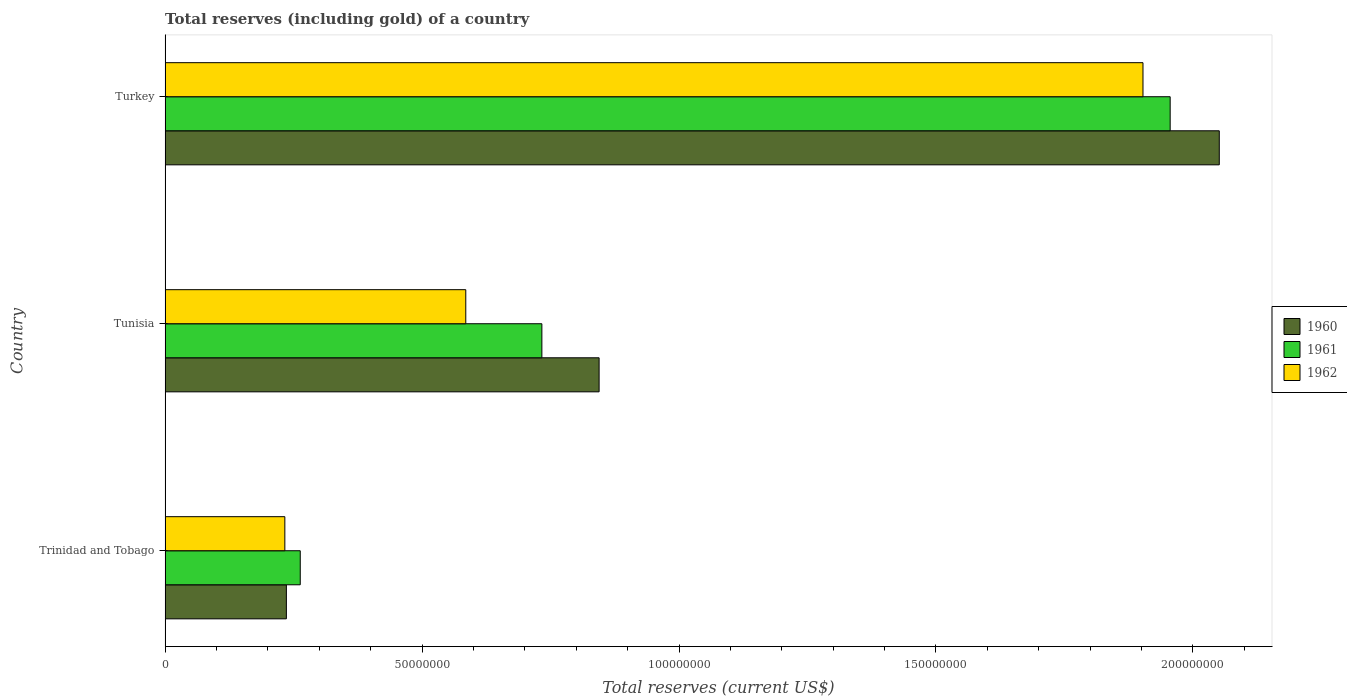How many different coloured bars are there?
Provide a short and direct response. 3. Are the number of bars on each tick of the Y-axis equal?
Ensure brevity in your answer.  Yes. How many bars are there on the 1st tick from the top?
Your answer should be compact. 3. What is the label of the 2nd group of bars from the top?
Your response must be concise. Tunisia. What is the total reserves (including gold) in 1960 in Tunisia?
Offer a very short reply. 8.45e+07. Across all countries, what is the maximum total reserves (including gold) in 1962?
Provide a short and direct response. 1.90e+08. Across all countries, what is the minimum total reserves (including gold) in 1960?
Your answer should be very brief. 2.36e+07. In which country was the total reserves (including gold) in 1960 minimum?
Your response must be concise. Trinidad and Tobago. What is the total total reserves (including gold) in 1960 in the graph?
Your response must be concise. 3.13e+08. What is the difference between the total reserves (including gold) in 1960 in Trinidad and Tobago and that in Tunisia?
Your answer should be very brief. -6.09e+07. What is the difference between the total reserves (including gold) in 1960 in Tunisia and the total reserves (including gold) in 1962 in Trinidad and Tobago?
Give a very brief answer. 6.12e+07. What is the average total reserves (including gold) in 1960 per country?
Ensure brevity in your answer.  1.04e+08. What is the difference between the total reserves (including gold) in 1962 and total reserves (including gold) in 1960 in Turkey?
Provide a short and direct response. -1.48e+07. In how many countries, is the total reserves (including gold) in 1962 greater than 150000000 US$?
Give a very brief answer. 1. What is the ratio of the total reserves (including gold) in 1962 in Trinidad and Tobago to that in Tunisia?
Your response must be concise. 0.4. What is the difference between the highest and the second highest total reserves (including gold) in 1960?
Offer a very short reply. 1.21e+08. What is the difference between the highest and the lowest total reserves (including gold) in 1960?
Provide a succinct answer. 1.82e+08. What does the 1st bar from the top in Trinidad and Tobago represents?
Provide a succinct answer. 1962. What does the 2nd bar from the bottom in Tunisia represents?
Provide a short and direct response. 1961. How many bars are there?
Provide a succinct answer. 9. How many countries are there in the graph?
Your answer should be compact. 3. What is the difference between two consecutive major ticks on the X-axis?
Offer a terse response. 5.00e+07. Does the graph contain any zero values?
Provide a short and direct response. No. How are the legend labels stacked?
Give a very brief answer. Vertical. What is the title of the graph?
Your response must be concise. Total reserves (including gold) of a country. What is the label or title of the X-axis?
Provide a succinct answer. Total reserves (current US$). What is the Total reserves (current US$) of 1960 in Trinidad and Tobago?
Your response must be concise. 2.36e+07. What is the Total reserves (current US$) of 1961 in Trinidad and Tobago?
Your answer should be compact. 2.63e+07. What is the Total reserves (current US$) of 1962 in Trinidad and Tobago?
Give a very brief answer. 2.33e+07. What is the Total reserves (current US$) in 1960 in Tunisia?
Give a very brief answer. 8.45e+07. What is the Total reserves (current US$) in 1961 in Tunisia?
Provide a succinct answer. 7.33e+07. What is the Total reserves (current US$) of 1962 in Tunisia?
Provide a succinct answer. 5.85e+07. What is the Total reserves (current US$) of 1960 in Turkey?
Your answer should be very brief. 2.05e+08. What is the Total reserves (current US$) in 1961 in Turkey?
Make the answer very short. 1.96e+08. What is the Total reserves (current US$) in 1962 in Turkey?
Your answer should be very brief. 1.90e+08. Across all countries, what is the maximum Total reserves (current US$) of 1960?
Provide a short and direct response. 2.05e+08. Across all countries, what is the maximum Total reserves (current US$) in 1961?
Provide a short and direct response. 1.96e+08. Across all countries, what is the maximum Total reserves (current US$) in 1962?
Provide a succinct answer. 1.90e+08. Across all countries, what is the minimum Total reserves (current US$) in 1960?
Offer a very short reply. 2.36e+07. Across all countries, what is the minimum Total reserves (current US$) in 1961?
Ensure brevity in your answer.  2.63e+07. Across all countries, what is the minimum Total reserves (current US$) of 1962?
Make the answer very short. 2.33e+07. What is the total Total reserves (current US$) of 1960 in the graph?
Your answer should be compact. 3.13e+08. What is the total Total reserves (current US$) of 1961 in the graph?
Offer a very short reply. 2.95e+08. What is the total Total reserves (current US$) in 1962 in the graph?
Your answer should be compact. 2.72e+08. What is the difference between the Total reserves (current US$) in 1960 in Trinidad and Tobago and that in Tunisia?
Your answer should be very brief. -6.09e+07. What is the difference between the Total reserves (current US$) in 1961 in Trinidad and Tobago and that in Tunisia?
Offer a very short reply. -4.70e+07. What is the difference between the Total reserves (current US$) in 1962 in Trinidad and Tobago and that in Tunisia?
Your answer should be compact. -3.52e+07. What is the difference between the Total reserves (current US$) of 1960 in Trinidad and Tobago and that in Turkey?
Provide a short and direct response. -1.82e+08. What is the difference between the Total reserves (current US$) of 1961 in Trinidad and Tobago and that in Turkey?
Offer a terse response. -1.69e+08. What is the difference between the Total reserves (current US$) of 1962 in Trinidad and Tobago and that in Turkey?
Make the answer very short. -1.67e+08. What is the difference between the Total reserves (current US$) of 1960 in Tunisia and that in Turkey?
Make the answer very short. -1.21e+08. What is the difference between the Total reserves (current US$) in 1961 in Tunisia and that in Turkey?
Your response must be concise. -1.22e+08. What is the difference between the Total reserves (current US$) in 1962 in Tunisia and that in Turkey?
Offer a terse response. -1.32e+08. What is the difference between the Total reserves (current US$) in 1960 in Trinidad and Tobago and the Total reserves (current US$) in 1961 in Tunisia?
Ensure brevity in your answer.  -4.97e+07. What is the difference between the Total reserves (current US$) in 1960 in Trinidad and Tobago and the Total reserves (current US$) in 1962 in Tunisia?
Ensure brevity in your answer.  -3.49e+07. What is the difference between the Total reserves (current US$) in 1961 in Trinidad and Tobago and the Total reserves (current US$) in 1962 in Tunisia?
Make the answer very short. -3.22e+07. What is the difference between the Total reserves (current US$) in 1960 in Trinidad and Tobago and the Total reserves (current US$) in 1961 in Turkey?
Ensure brevity in your answer.  -1.72e+08. What is the difference between the Total reserves (current US$) of 1960 in Trinidad and Tobago and the Total reserves (current US$) of 1962 in Turkey?
Your response must be concise. -1.67e+08. What is the difference between the Total reserves (current US$) in 1961 in Trinidad and Tobago and the Total reserves (current US$) in 1962 in Turkey?
Make the answer very short. -1.64e+08. What is the difference between the Total reserves (current US$) of 1960 in Tunisia and the Total reserves (current US$) of 1961 in Turkey?
Your answer should be compact. -1.11e+08. What is the difference between the Total reserves (current US$) in 1960 in Tunisia and the Total reserves (current US$) in 1962 in Turkey?
Provide a short and direct response. -1.06e+08. What is the difference between the Total reserves (current US$) in 1961 in Tunisia and the Total reserves (current US$) in 1962 in Turkey?
Provide a short and direct response. -1.17e+08. What is the average Total reserves (current US$) of 1960 per country?
Give a very brief answer. 1.04e+08. What is the average Total reserves (current US$) of 1961 per country?
Ensure brevity in your answer.  9.84e+07. What is the average Total reserves (current US$) of 1962 per country?
Ensure brevity in your answer.  9.07e+07. What is the difference between the Total reserves (current US$) in 1960 and Total reserves (current US$) in 1961 in Trinidad and Tobago?
Your response must be concise. -2.70e+06. What is the difference between the Total reserves (current US$) of 1960 and Total reserves (current US$) of 1961 in Tunisia?
Ensure brevity in your answer.  1.11e+07. What is the difference between the Total reserves (current US$) in 1960 and Total reserves (current US$) in 1962 in Tunisia?
Your response must be concise. 2.59e+07. What is the difference between the Total reserves (current US$) in 1961 and Total reserves (current US$) in 1962 in Tunisia?
Ensure brevity in your answer.  1.48e+07. What is the difference between the Total reserves (current US$) of 1960 and Total reserves (current US$) of 1961 in Turkey?
Give a very brief answer. 9.56e+06. What is the difference between the Total reserves (current US$) of 1960 and Total reserves (current US$) of 1962 in Turkey?
Offer a very short reply. 1.48e+07. What is the difference between the Total reserves (current US$) in 1961 and Total reserves (current US$) in 1962 in Turkey?
Offer a very short reply. 5.29e+06. What is the ratio of the Total reserves (current US$) in 1960 in Trinidad and Tobago to that in Tunisia?
Offer a very short reply. 0.28. What is the ratio of the Total reserves (current US$) of 1961 in Trinidad and Tobago to that in Tunisia?
Make the answer very short. 0.36. What is the ratio of the Total reserves (current US$) in 1962 in Trinidad and Tobago to that in Tunisia?
Your answer should be very brief. 0.4. What is the ratio of the Total reserves (current US$) in 1960 in Trinidad and Tobago to that in Turkey?
Offer a very short reply. 0.12. What is the ratio of the Total reserves (current US$) in 1961 in Trinidad and Tobago to that in Turkey?
Your response must be concise. 0.13. What is the ratio of the Total reserves (current US$) in 1962 in Trinidad and Tobago to that in Turkey?
Offer a very short reply. 0.12. What is the ratio of the Total reserves (current US$) of 1960 in Tunisia to that in Turkey?
Make the answer very short. 0.41. What is the ratio of the Total reserves (current US$) in 1961 in Tunisia to that in Turkey?
Your answer should be compact. 0.37. What is the ratio of the Total reserves (current US$) in 1962 in Tunisia to that in Turkey?
Keep it short and to the point. 0.31. What is the difference between the highest and the second highest Total reserves (current US$) of 1960?
Your answer should be compact. 1.21e+08. What is the difference between the highest and the second highest Total reserves (current US$) in 1961?
Your response must be concise. 1.22e+08. What is the difference between the highest and the second highest Total reserves (current US$) of 1962?
Offer a very short reply. 1.32e+08. What is the difference between the highest and the lowest Total reserves (current US$) in 1960?
Your response must be concise. 1.82e+08. What is the difference between the highest and the lowest Total reserves (current US$) in 1961?
Keep it short and to the point. 1.69e+08. What is the difference between the highest and the lowest Total reserves (current US$) in 1962?
Keep it short and to the point. 1.67e+08. 